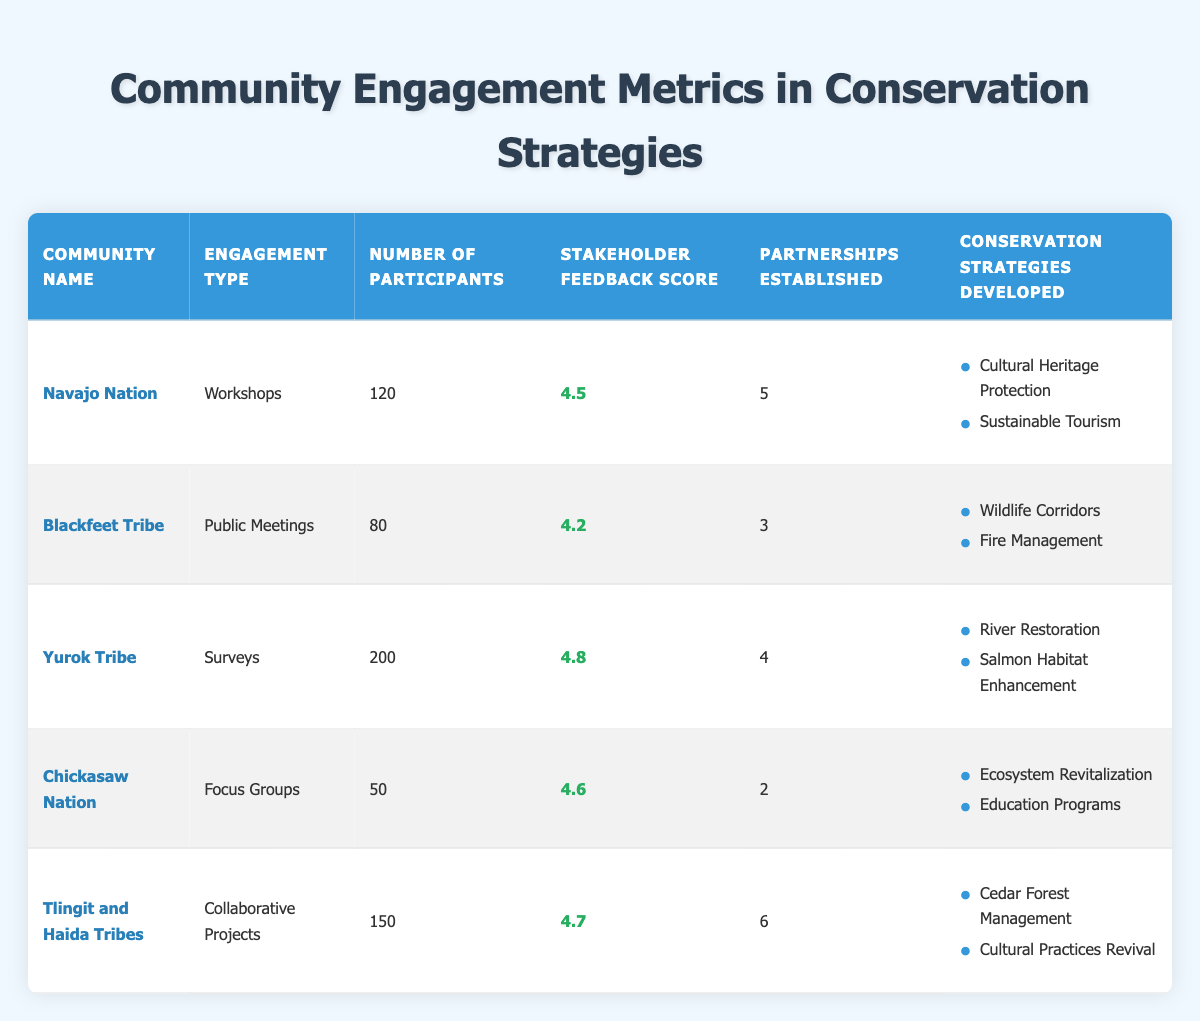What is the highest stakeholder feedback score among the communities? The highest stakeholder feedback score can be found by examining the scores in the "Stakeholder Feedback Score" column. The scores are 4.5, 4.2, 4.8, 4.6, and 4.7, with 4.8 being the highest. This score belongs to the Yurok Tribe.
Answer: 4.8 How many partnerships were established in total across all communities? To find the total number of partnerships established, we sum the values in the "Partnerships Established" column: 5 + 3 + 4 + 2 + 6 = 20.
Answer: 20 Did the Chickasaw Nation develop any conservation strategies related to wildlife? By examining the conservation strategies developed by the Chickasaw Nation, we see that they focused on "Ecosystem Revitalization" and "Education Programs," neither of which mentions wildlife. Therefore, the answer is no.
Answer: No Which community had the greatest number of participants in their engagement activities? The number of participants is listed in the "Number of Participants" column. The values are 120, 80, 200, 50, and 150. The greatest number of participants is 200, which is associated with the Yurok Tribe.
Answer: Yurok Tribe What is the average number of partnerships established per community? To calculate the average, we first sum the partnerships established: 5 + 3 + 4 + 2 + 6 = 20. Since there are 5 communities, we divide the total by 5: 20 / 5 = 4.
Answer: 4 Which engagement type had the fewest participants? Looking at the "Engagement Type" and "Number of Participants" columns, the Chickasaw Nation had 50 participants, which is fewer than the others (120, 80, 200, and 150).
Answer: Focus Groups Are there any conservation strategies focused on cultural aspects among the communities? By reviewing the strategies developed, the Navajo Nation focuses on "Cultural Heritage Protection," and the Tlingit and Haida Tribes focus on "Cultural Practices Revival." This indicates that yes, there are strategies focused on cultural aspects.
Answer: Yes What was the stakeholder feedback score for the Blackfeet Tribe? The stakeholder feedback score for the Blackfeet Tribe is located in the "Stakeholder Feedback Score" column, which shows a score of 4.2.
Answer: 4.2 Which community established the most partnerships, and what type of engagement did they use? The Tlingit and Haida Tribes established the most partnerships, which is 6. They engaged in "Collaborative Projects."
Answer: Tlingit and Haida Tribes, Collaborative Projects 